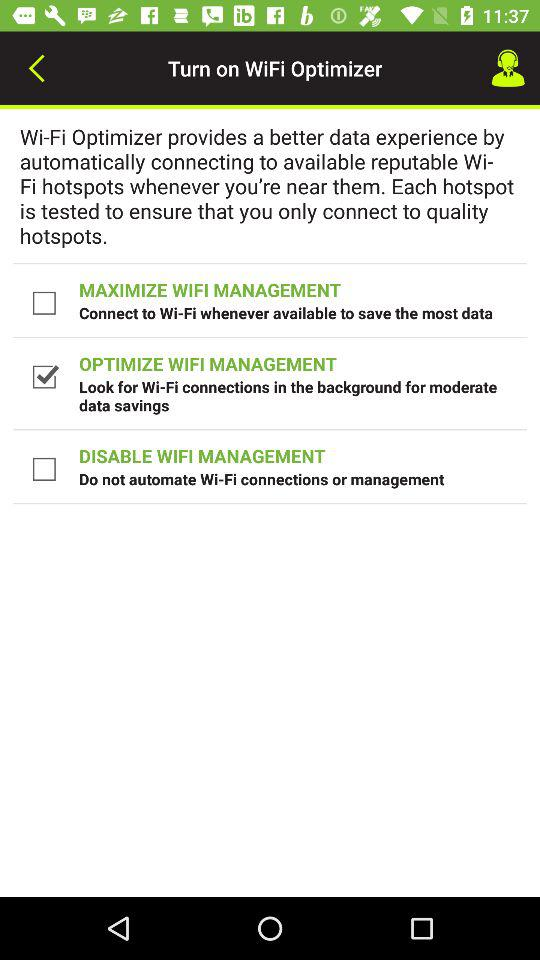What is the status of "OPTIMIZE WIFI MANAGEMENT"? The status is "on". 